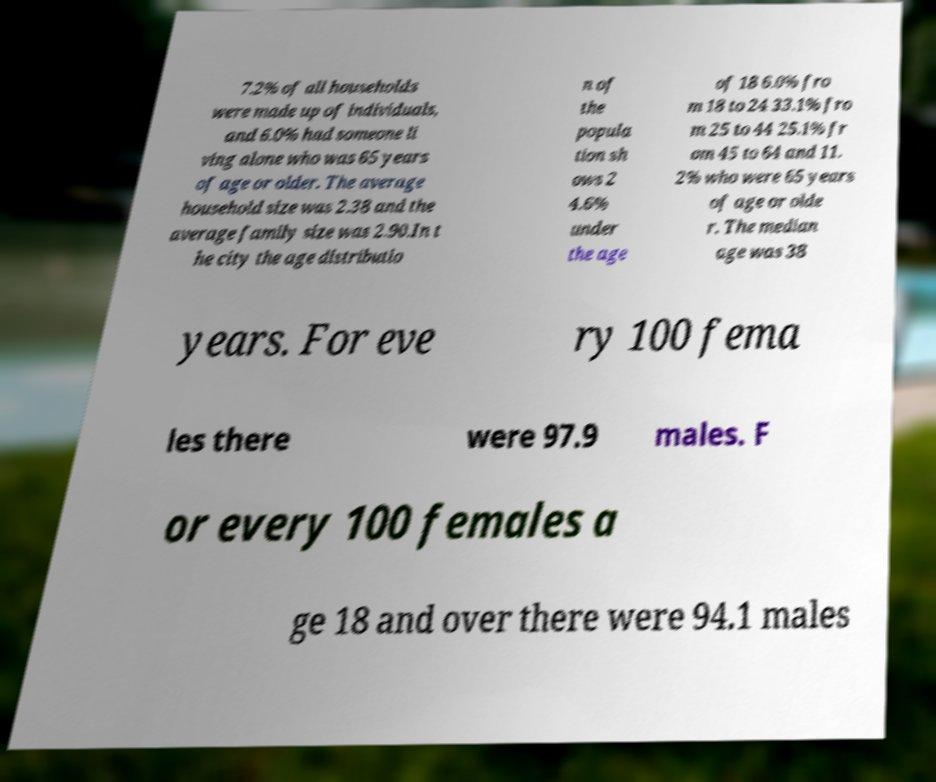Can you accurately transcribe the text from the provided image for me? 7.2% of all households were made up of individuals, and 6.0% had someone li ving alone who was 65 years of age or older. The average household size was 2.38 and the average family size was 2.90.In t he city the age distributio n of the popula tion sh ows 2 4.6% under the age of 18 6.0% fro m 18 to 24 33.1% fro m 25 to 44 25.1% fr om 45 to 64 and 11. 2% who were 65 years of age or olde r. The median age was 38 years. For eve ry 100 fema les there were 97.9 males. F or every 100 females a ge 18 and over there were 94.1 males 